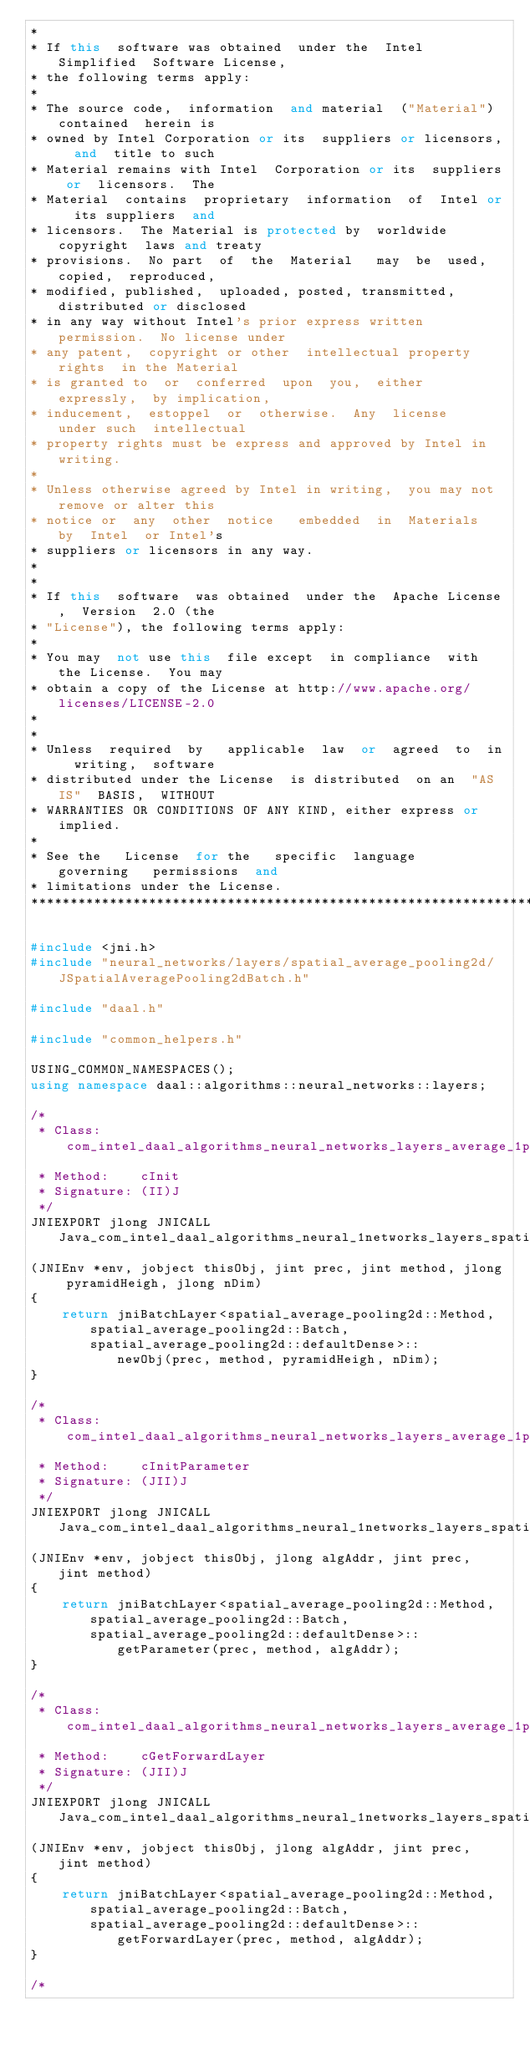<code> <loc_0><loc_0><loc_500><loc_500><_C++_>*
* If this  software was obtained  under the  Intel Simplified  Software License,
* the following terms apply:
*
* The source code,  information  and material  ("Material") contained  herein is
* owned by Intel Corporation or its  suppliers or licensors,  and  title to such
* Material remains with Intel  Corporation or its  suppliers or  licensors.  The
* Material  contains  proprietary  information  of  Intel or  its suppliers  and
* licensors.  The Material is protected by  worldwide copyright  laws and treaty
* provisions.  No part  of  the  Material   may  be  used,  copied,  reproduced,
* modified, published,  uploaded, posted, transmitted,  distributed or disclosed
* in any way without Intel's prior express written permission.  No license under
* any patent,  copyright or other  intellectual property rights  in the Material
* is granted to  or  conferred  upon  you,  either   expressly,  by implication,
* inducement,  estoppel  or  otherwise.  Any  license   under such  intellectual
* property rights must be express and approved by Intel in writing.
*
* Unless otherwise agreed by Intel in writing,  you may not remove or alter this
* notice or  any  other  notice   embedded  in  Materials  by  Intel  or Intel's
* suppliers or licensors in any way.
*
*
* If this  software  was obtained  under the  Apache License,  Version  2.0 (the
* "License"), the following terms apply:
*
* You may  not use this  file except  in compliance  with  the License.  You may
* obtain a copy of the License at http://www.apache.org/licenses/LICENSE-2.0
*
*
* Unless  required  by   applicable  law  or  agreed  to  in  writing,  software
* distributed under the License  is distributed  on an  "AS IS"  BASIS,  WITHOUT
* WARRANTIES OR CONDITIONS OF ANY KIND, either express or implied.
*
* See the   License  for the   specific  language   governing   permissions  and
* limitations under the License.
*******************************************************************************/

#include <jni.h>
#include "neural_networks/layers/spatial_average_pooling2d/JSpatialAveragePooling2dBatch.h"

#include "daal.h"

#include "common_helpers.h"

USING_COMMON_NAMESPACES();
using namespace daal::algorithms::neural_networks::layers;

/*
 * Class:     com_intel_daal_algorithms_neural_networks_layers_average_1pooling2d_SpatialAveragePooling2dBatch
 * Method:    cInit
 * Signature: (II)J
 */
JNIEXPORT jlong JNICALL Java_com_intel_daal_algorithms_neural_1networks_layers_spatial_1average_1pooling2d_SpatialAveragePooling2dBatch_cInit
(JNIEnv *env, jobject thisObj, jint prec, jint method, jlong pyramidHeigh, jlong nDim)
{
    return jniBatchLayer<spatial_average_pooling2d::Method, spatial_average_pooling2d::Batch, spatial_average_pooling2d::defaultDense>::
           newObj(prec, method, pyramidHeigh, nDim);
}

/*
 * Class:     com_intel_daal_algorithms_neural_networks_layers_average_1pooling2d_SpatialAveragePooling2dBatch
 * Method:    cInitParameter
 * Signature: (JII)J
 */
JNIEXPORT jlong JNICALL Java_com_intel_daal_algorithms_neural_1networks_layers_spatial_1average_1pooling2d_SpatialAveragePooling2dBatch_cInitParameter
(JNIEnv *env, jobject thisObj, jlong algAddr, jint prec, jint method)
{
    return jniBatchLayer<spatial_average_pooling2d::Method, spatial_average_pooling2d::Batch, spatial_average_pooling2d::defaultDense>::
           getParameter(prec, method, algAddr);
}

/*
 * Class:     com_intel_daal_algorithms_neural_networks_layers_average_1pooling2d_SpatialAveragePooling2dBatch
 * Method:    cGetForwardLayer
 * Signature: (JII)J
 */
JNIEXPORT jlong JNICALL Java_com_intel_daal_algorithms_neural_1networks_layers_spatial_1average_1pooling2d_SpatialAveragePooling2dBatch_cGetForwardLayer
(JNIEnv *env, jobject thisObj, jlong algAddr, jint prec, jint method)
{
    return jniBatchLayer<spatial_average_pooling2d::Method, spatial_average_pooling2d::Batch, spatial_average_pooling2d::defaultDense>::
           getForwardLayer(prec, method, algAddr);
}

/*</code> 